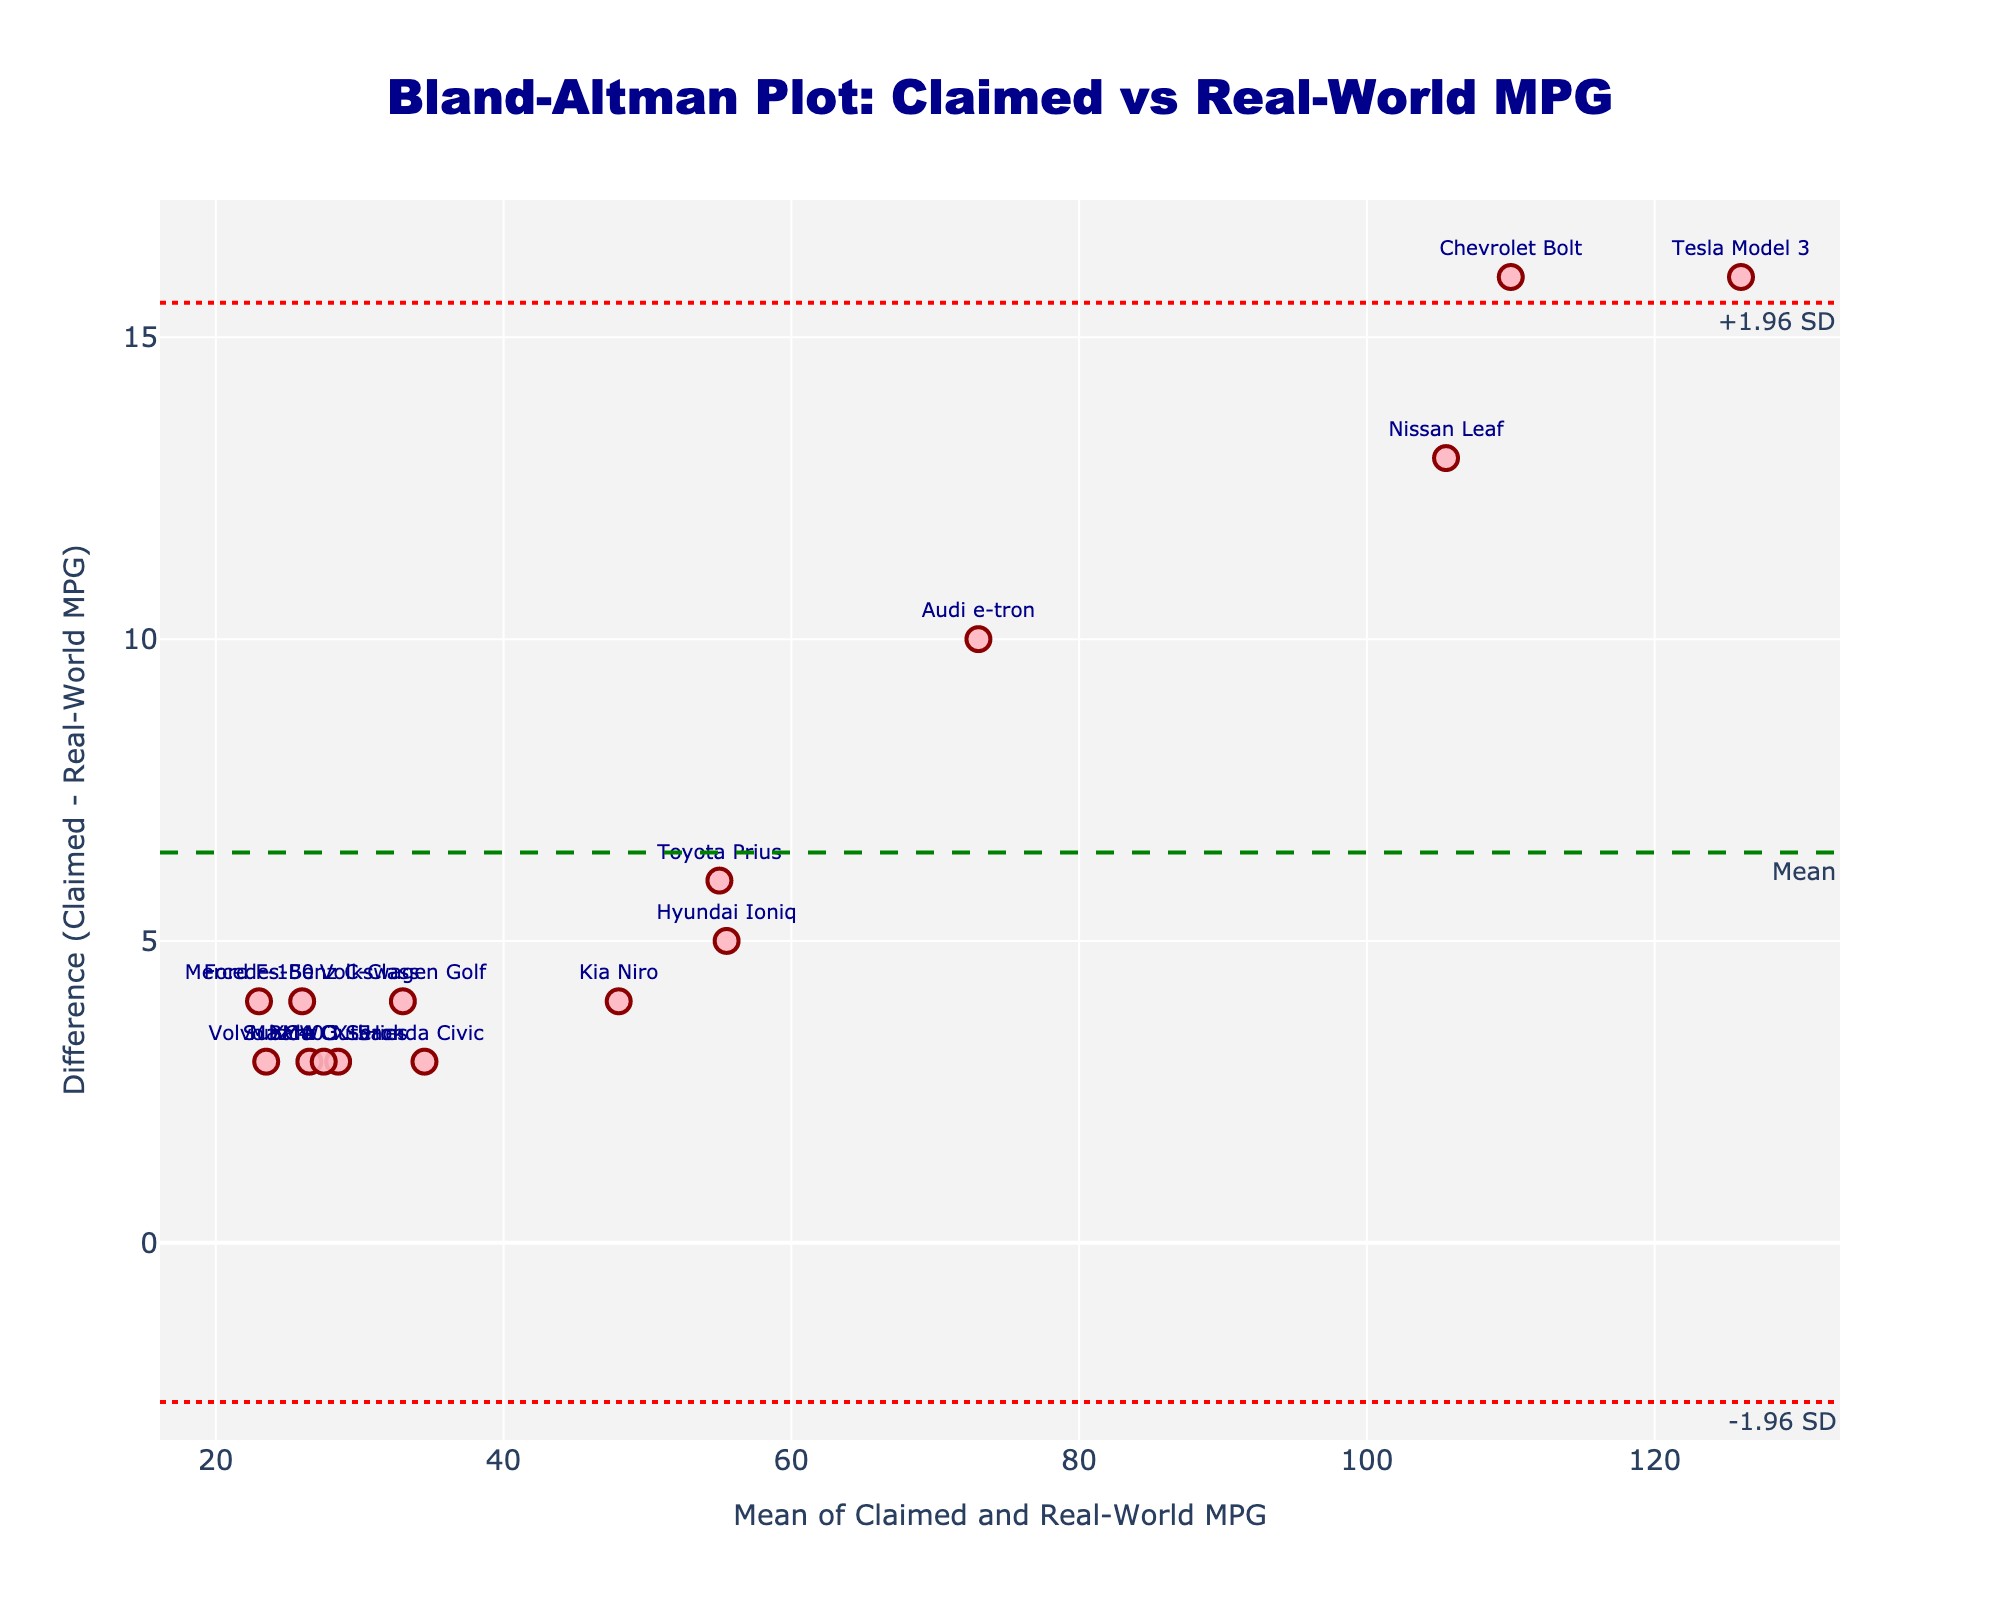How many data points are there in the plot? You can count the number of markers present on the plot, each representing a different vehicle. Based on the input data, we have one marker per vehicle type, so we can count the total number of vehicle types.
Answer: 15 What are the axes titles in the plot? Observing the plot, the x-axis title is mentioned as "Mean of Claimed and Real-World MPG" and the y-axis as "Difference (Claimed - Real-World MPG)". These titles describe what the axes represent based on the data provided.
Answer: "Mean of Claimed and Real-World MPG"; "Difference (Claimed - Real-World MPG)" Which vehicle has the largest difference between Claimed MPG and Real-World MPG? By examining the vertical position of the markers (differences), the Tesla Model 3 shows the largest difference.
Answer: Tesla Model 3 What is the mean difference between Claimed MPG and Real-World MPG? The mean difference line is marked on the plot with a green dashed line labeled "Mean". Reading off the value from this line gives us the mean difference.
Answer: ~6 What are the upper and lower limits of agreement in the plot? The upper and lower limits of agreement are represented by red dotted lines labeled "+1.96 SD" and "-1.96 SD". Reading off the corresponding values from these lines provides the limits.
Answer: ~18.6 and ~-6.6 Which vehicle has the smallest mean of Claimed and Real-World MPG? The x-axis represents the mean of Claimed and Real-World MPG. By identifying the marker closest to the origin on the x-axis, we can find the vehicle with the smallest mean value.
Answer: Ford F-150 What can be inferred if a vehicle's marker is above the mean difference line? Markers above the mean difference line represent vehicles where Claimed MPG is greater than Real-World MPG. This is evident from positive differences shown on the plot.
Answer: Claimed MPG > Real-World MPG Is there any vehicle where the Claimed MPG is equal to the Real-World MPG? To determine equality, look for a marker that sits on the y=0 line (no difference between Claimed and Real-World MPG). As per the plot, there are no markers on the y=0 line.
Answer: No For which vehicle is the difference closest to zero? By identifying the marker nearest to the y=0 line, it becomes apparent which vehicle has the smallest difference in Claimed versus Real-World MPG.
Answer: Subaru Outback Which vehicle has the highest mean of Claimed and Real-World MPG? The x-axis represents the mean of the two measures, and by identifying the marker farthest to the right, the vehicle with the highest mean can be found.
Answer: Tesla Model 3 